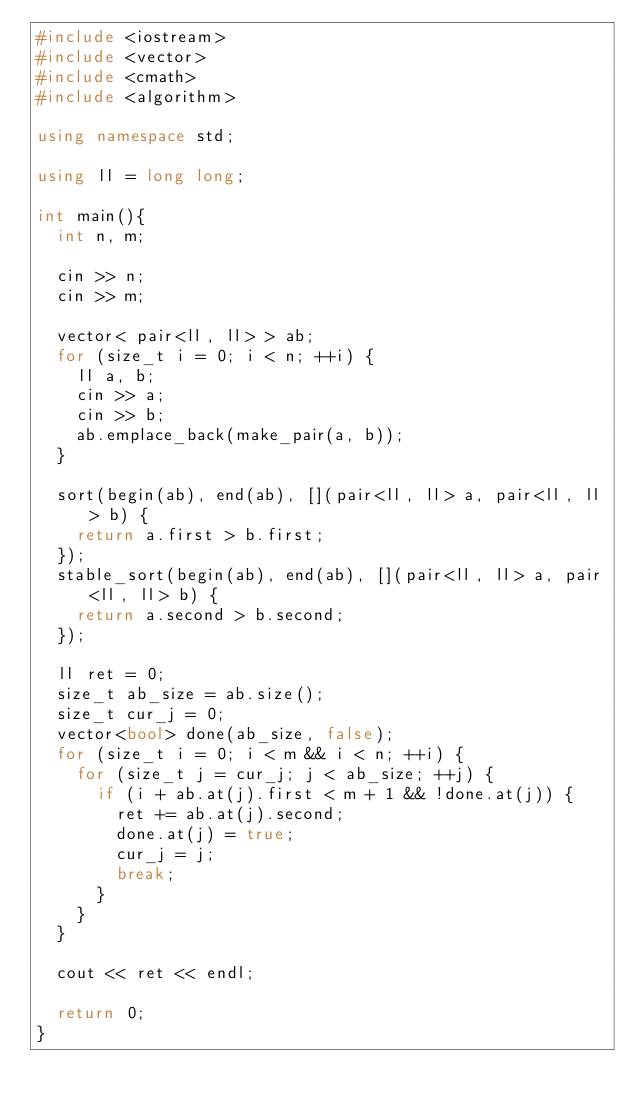<code> <loc_0><loc_0><loc_500><loc_500><_C++_>#include <iostream>
#include <vector>
#include <cmath>
#include <algorithm>

using namespace std;

using ll = long long;

int main(){
	int n, m;

	cin >> n;
	cin >> m;

	vector< pair<ll, ll> > ab;
	for (size_t i = 0; i < n; ++i) {
		ll a, b;
		cin >> a;
		cin >> b;
		ab.emplace_back(make_pair(a, b));
	}
	
	sort(begin(ab), end(ab), [](pair<ll, ll> a, pair<ll, ll> b) {
		return a.first > b.first;
	});
	stable_sort(begin(ab), end(ab), [](pair<ll, ll> a, pair<ll, ll> b) {
		return a.second > b.second;
	});
	
	ll ret = 0;
	size_t ab_size = ab.size();
	size_t cur_j = 0;
	vector<bool> done(ab_size, false);
	for (size_t i = 0; i < m && i < n; ++i) {
		for (size_t j = cur_j; j < ab_size; ++j) {
			if (i + ab.at(j).first < m + 1 && !done.at(j)) {
				ret += ab.at(j).second;
				done.at(j) = true;
				cur_j = j;
				break;
			}
		}
	}

	cout << ret << endl;
	
	return 0;
}</code> 